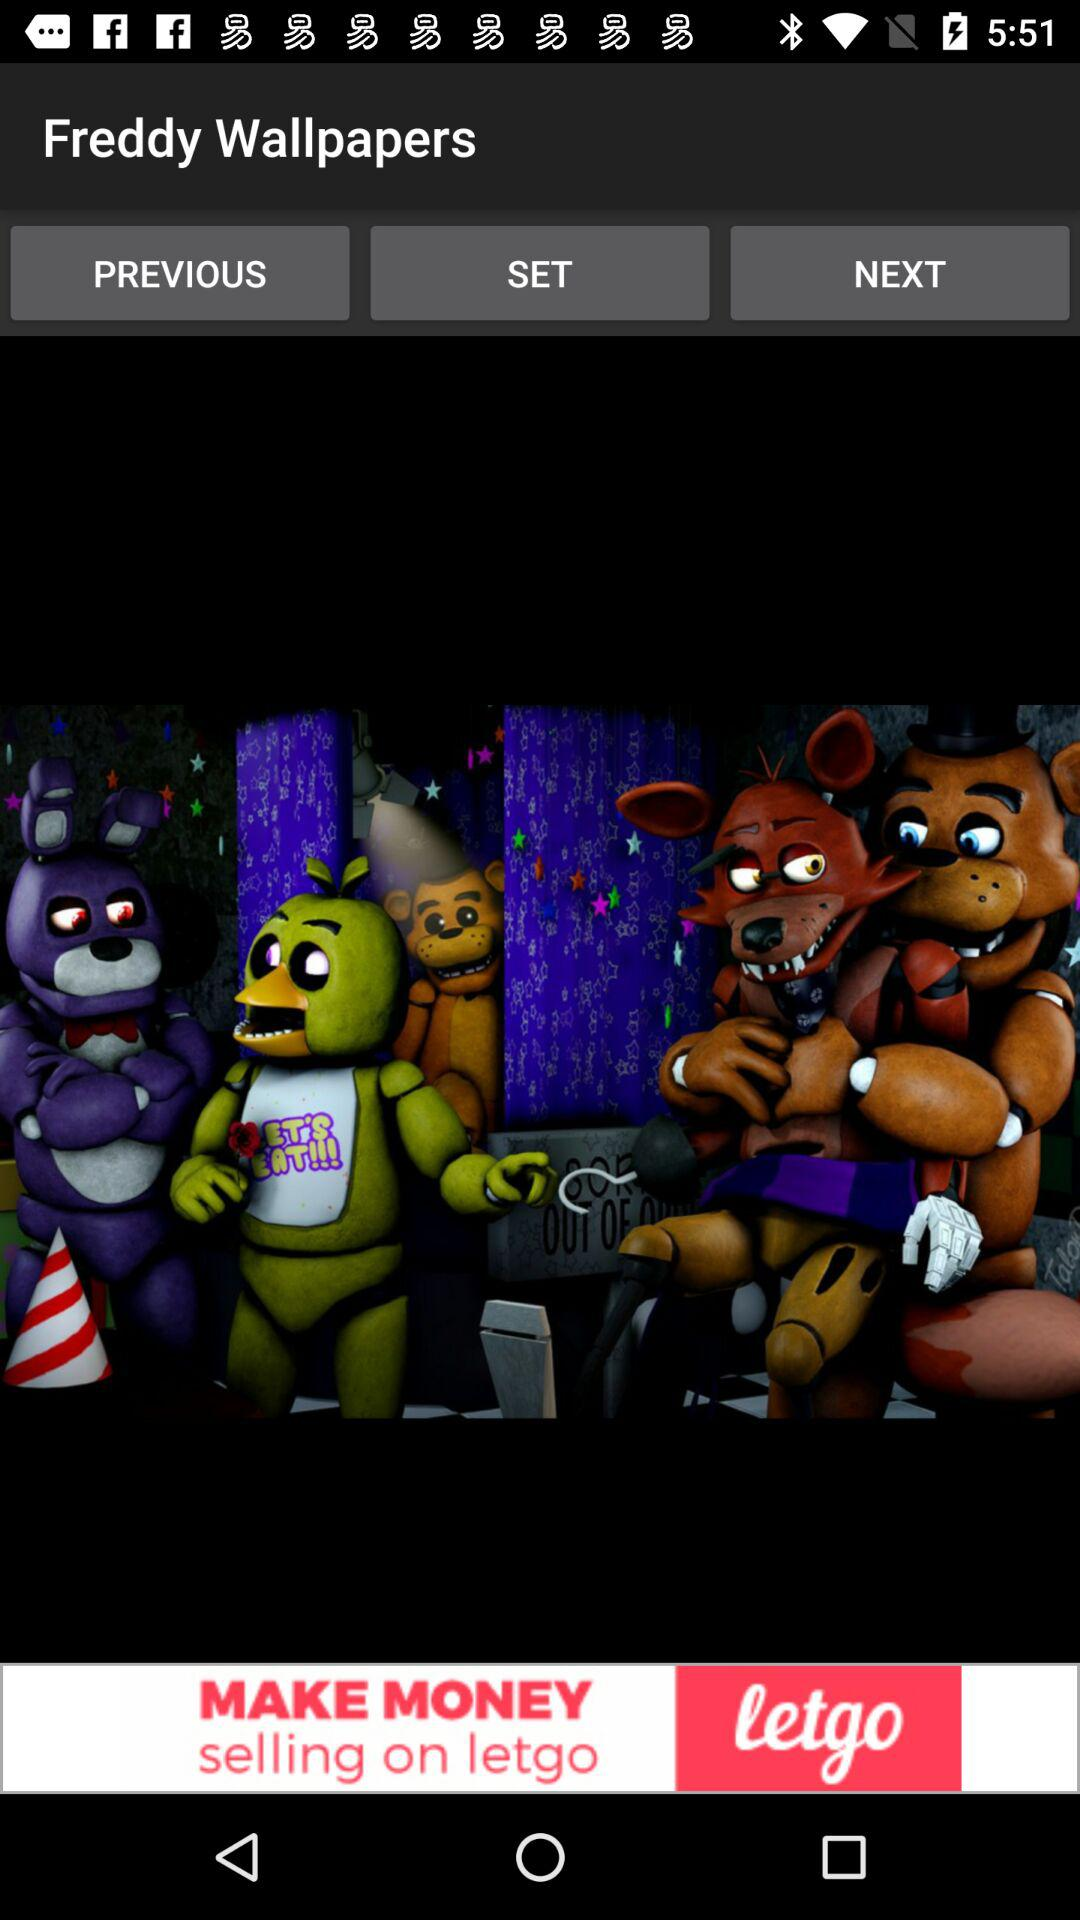What is the application name? The application name is "Freddy Wallpapers". 